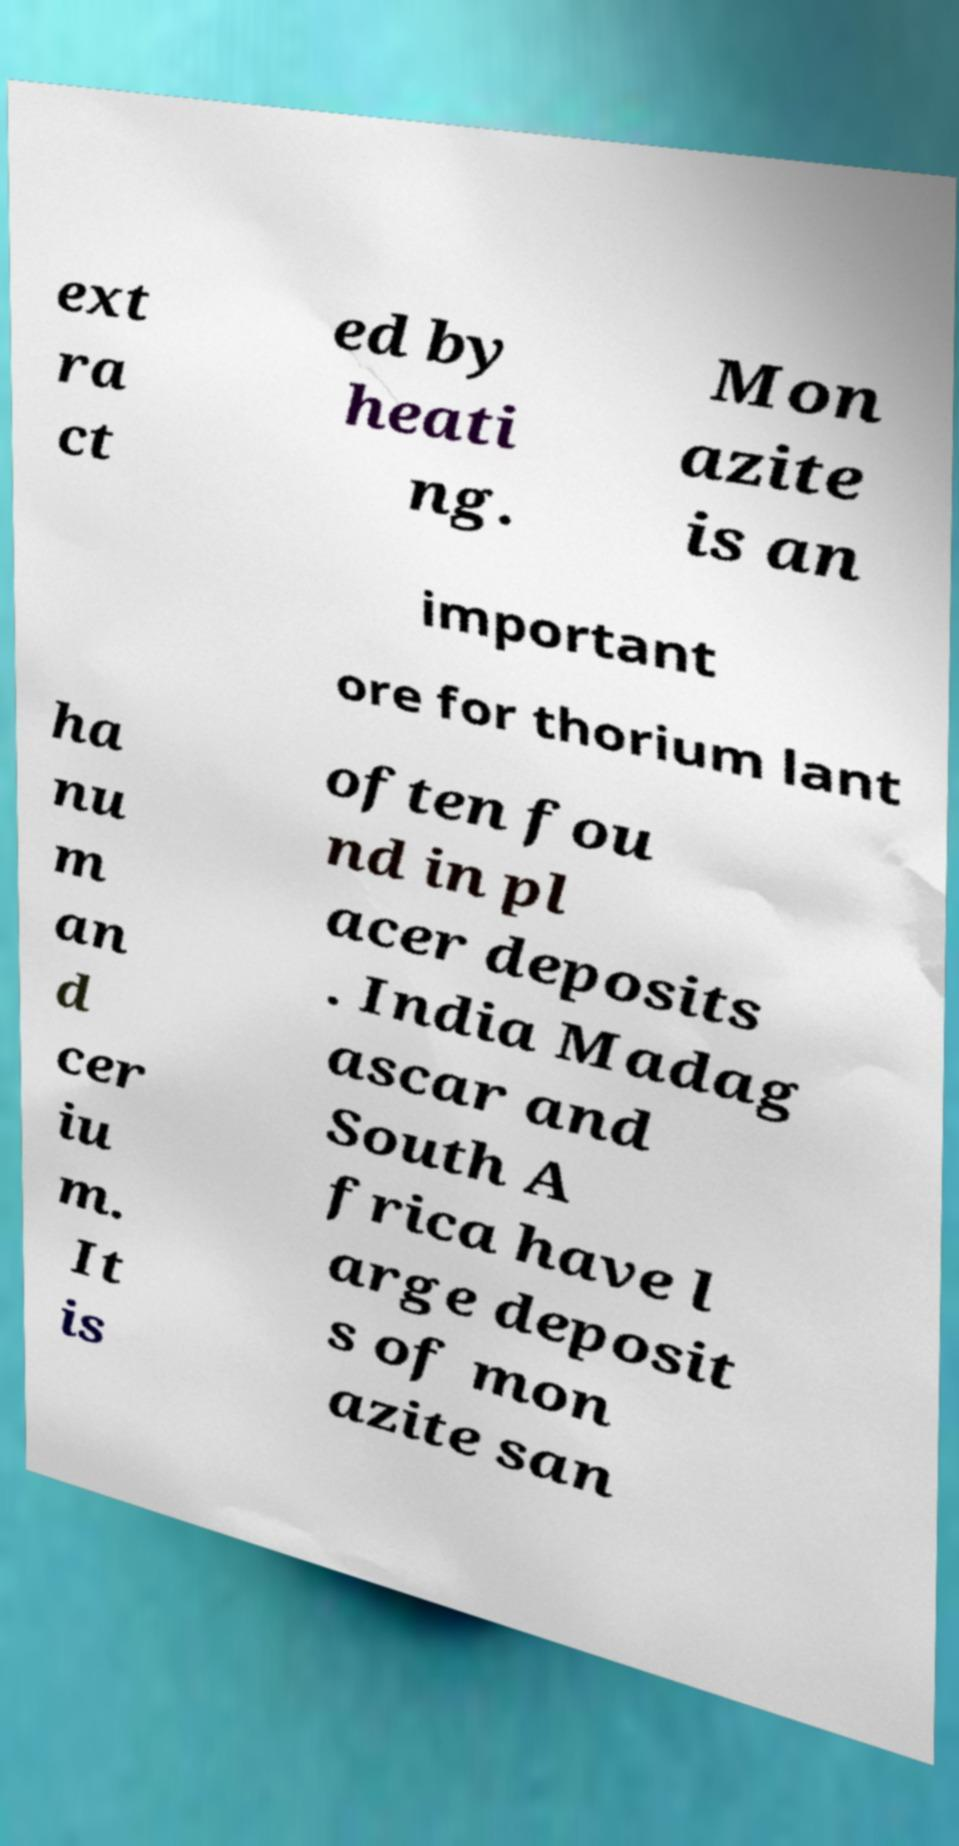Could you extract and type out the text from this image? ext ra ct ed by heati ng. Mon azite is an important ore for thorium lant ha nu m an d cer iu m. It is often fou nd in pl acer deposits . India Madag ascar and South A frica have l arge deposit s of mon azite san 